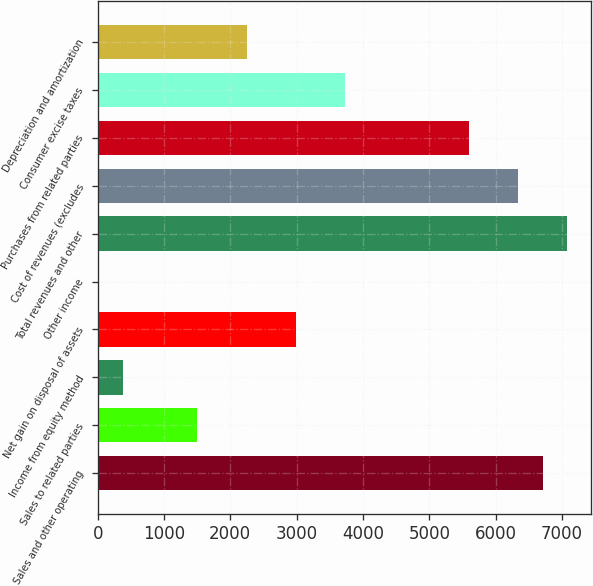Convert chart. <chart><loc_0><loc_0><loc_500><loc_500><bar_chart><fcel>Sales and other operating<fcel>Sales to related parties<fcel>Income from equity method<fcel>Net gain on disposal of assets<fcel>Other income<fcel>Total revenues and other<fcel>Cost of revenues (excludes<fcel>Purchases from related parties<fcel>Consumer excise taxes<fcel>Depreciation and amortization<nl><fcel>6709<fcel>1501<fcel>385<fcel>2989<fcel>13<fcel>7081<fcel>6337<fcel>5593<fcel>3733<fcel>2245<nl></chart> 